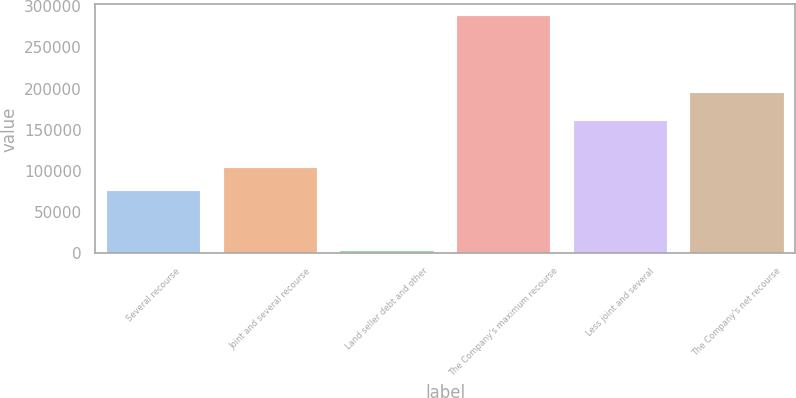Convert chart to OTSL. <chart><loc_0><loc_0><loc_500><loc_500><bar_chart><fcel>Several recourse<fcel>Joint and several recourse<fcel>Land seller debt and other<fcel>The Company's maximum recourse<fcel>Less joint and several<fcel>The Company's net recourse<nl><fcel>75238<fcel>103770<fcel>2420<fcel>287740<fcel>160834<fcel>194555<nl></chart> 